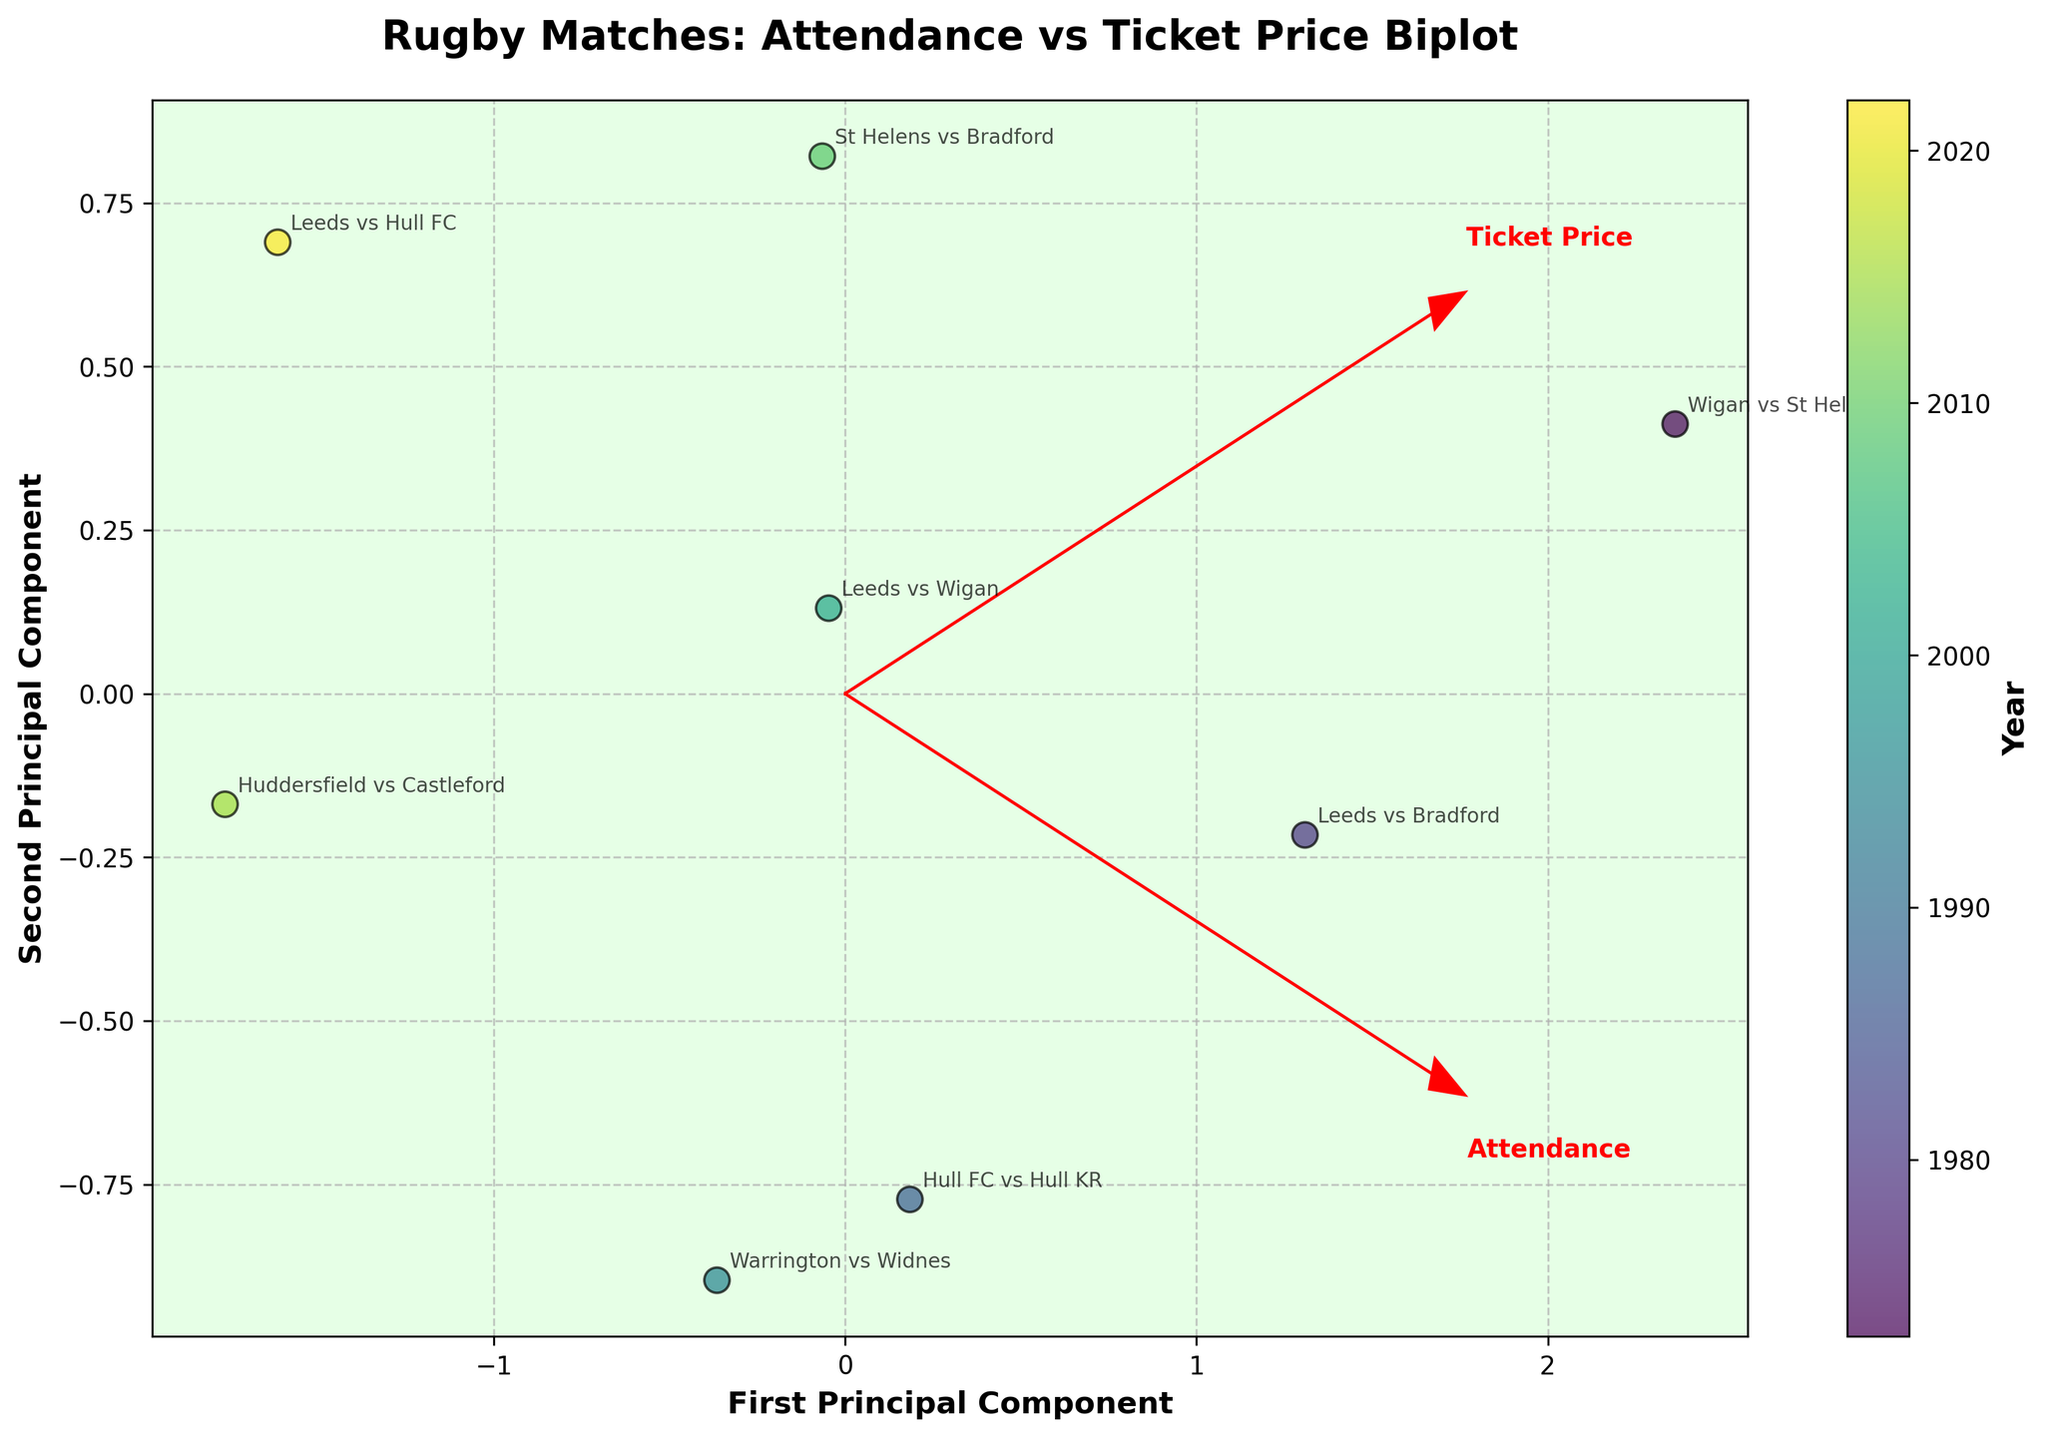How many matches are present in the plot? Count the number of different match labels on the biplot. There are 8 distinct match labels.
Answer: 8 What year had the lowest ticket price in the plot? Observe the color gradient indicating the years and look for the match label with the lowest ticket price (as shown by the direction of the Ticket Price vector). Wigan vs St Helens in 1973 has the lowest ticket price.
Answer: 1973 Which match had the highest attendance? Look at the match labels and their positions relative to the Attendance vector. The match farthest along the Attendance vector direction has the highest attendance. Wigan vs St Helens has the highest attendance.
Answer: Wigan vs St Helens What is the title of the plot? Read the title text at the top of the figure. The title is "Rugby Matches: Attendance vs Ticket Price Biplot".
Answer: Rugby Matches: Attendance vs Ticket Price Biplot Which match appears to have occurred most recently? Identify the match label corresponding to the most recent year, indicated by the color gradient. Leeds vs Hull FC occurred in 2022, the most recent year in the range.
Answer: Leeds vs Hull FC Compare the attendance of Hull FC vs Hull KR and Warrington vs Widnes. Which one had higher attendance? Check the positions of these two match labels relative to the Attendance vector. Hull FC vs Hull KR is further along the Attendance vector than Warrington vs Widnes.
Answer: Hull FC vs Hull KR In which year did the Leeds vs Wigan match occur? Look at the color gradient of the match label Leeds vs Wigan and correlate it with the colorbar indicating the years. Leeds vs Wigan occurred in 2002.
Answer: 2002 Which factor has a stronger influence on the first principal component, Attendance or Ticket Price? Observe the length of the vectors for Attendance and Ticket Price in the direction of the first principal component axis. The vector for Attendance appears to have a stronger influence.
Answer: Attendance 